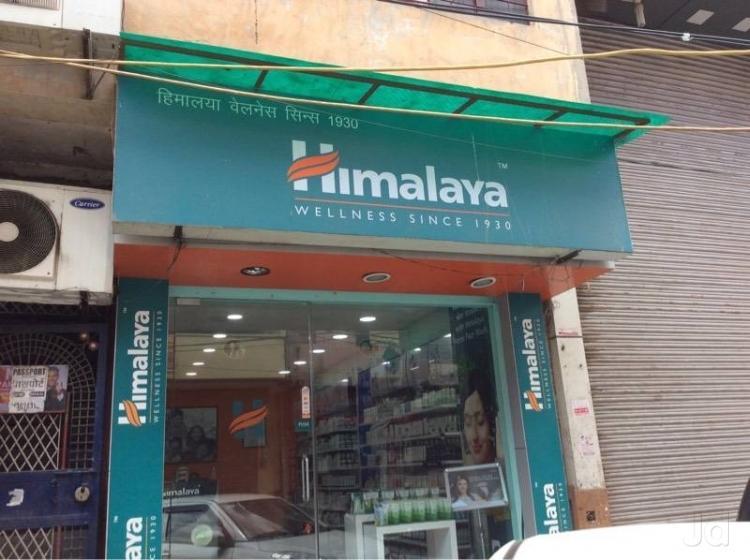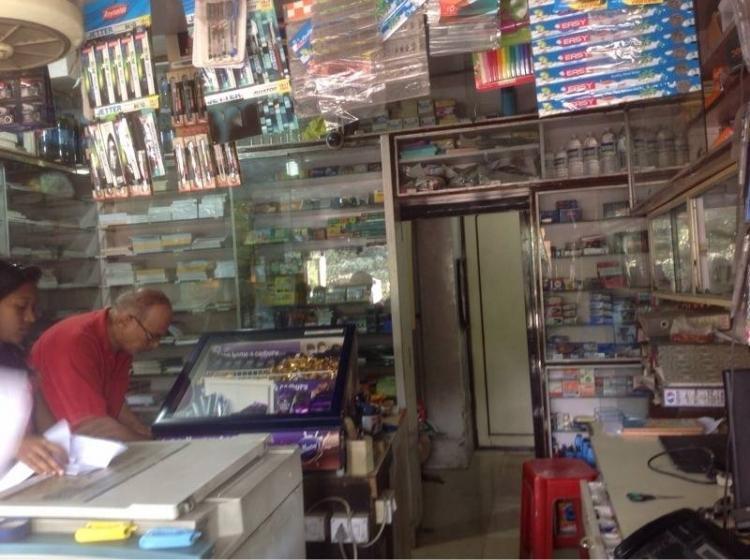The first image is the image on the left, the second image is the image on the right. For the images shown, is this caption "Both photos show the exterior of a book shop." true? Answer yes or no. No. 